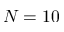Convert formula to latex. <formula><loc_0><loc_0><loc_500><loc_500>N = 1 0</formula> 